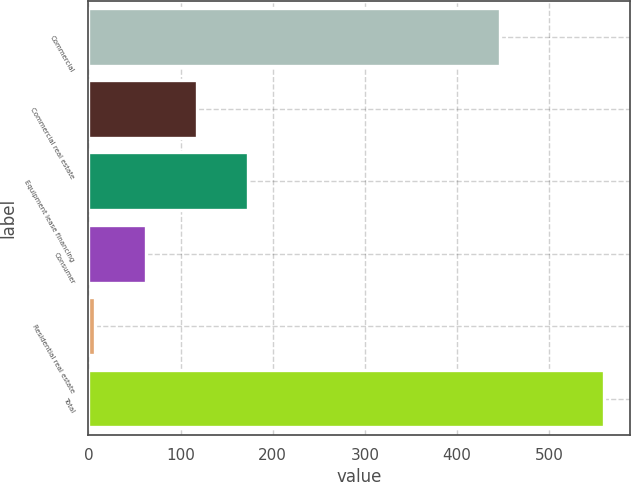<chart> <loc_0><loc_0><loc_500><loc_500><bar_chart><fcel>Commercial<fcel>Commercial real estate<fcel>Equipment lease financing<fcel>Consumer<fcel>Residential real estate<fcel>Total<nl><fcel>447<fcel>117.6<fcel>172.9<fcel>62.3<fcel>7<fcel>560<nl></chart> 